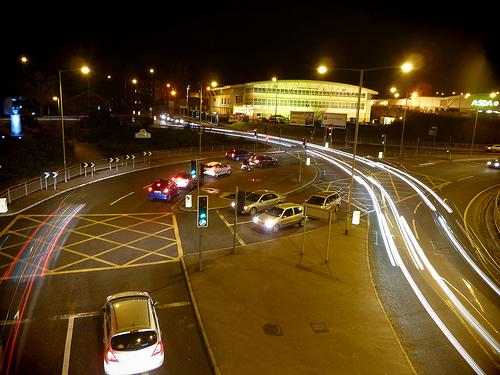State the significant architectural elements seen in this picture and their color. A large building with a rounded roof and white color, and a white building next to a business called Asda. Identify and describe the features of the traffic lights in the image. Two green traffic lights at the intersection on a pole with a red light in the background. Briefly describe the setting of this image as if describing it to someone who cannot see it. Busy city street at night, with vehicles stopped at an intersection and various signage and lights on poles. Write about the purpose of signages in the context of this picture. Signs with arrows indicating right turns, black and white signs on poles, and street signs to regulate traffic in the city. Describe the colors of the sky and the road in the picture. The sky is black, while the road is grey in color. Express the interaction between the road and its markings in the image. Yellow lines on the gray-colored road, with crisscrossed lines at the intersection and a concrete divider. Describe the ambiance created by the lighting in the image. Lights are on, illuminating streets, vehicles, and buildings, creating a yellowish glow in the dark night sky. Briefly discuss the position of the business called Asda in relation to the other elements in the picture. The business Asda is located to the right of a large white building and near a large intersection with traffic lights. Enumerate the types of vehicles and their color visible in the picture. A white SUV, a blue car with brake lights on, a silver sedan, a silver van, and a silver hatchback. Mention the primary object in the picture and the related object that draws attention. A white SUV at the intersection with a traffic light showing green signal in the background. 